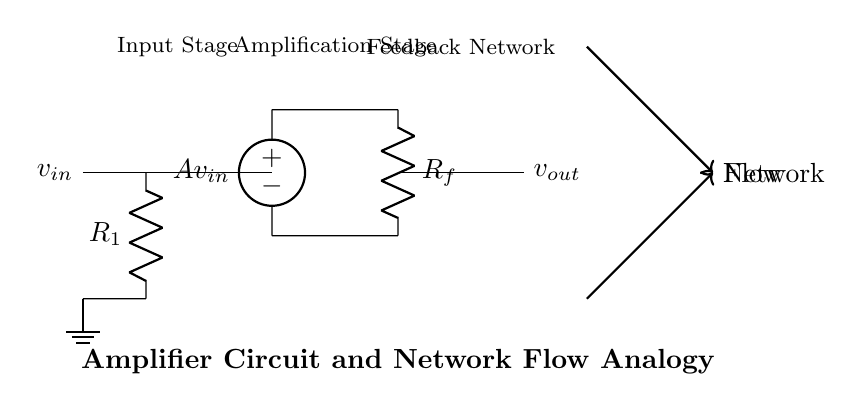what is the type of the amplifier used in the circuit? The circuit uses an operational amplifier, specifically an ideal one, as indicated by the configuration of the voltage source and resistors in the amplification stage.
Answer: operational amplifier what is the role of the resistor R1 in this circuit? Resistor R1 is a part of the input stage that determines the input impedance of the amplifier, working in conjunction with the input voltage to affect the initial current flow into the amplifier.
Answer: input impedance how does the feedback resistor Rf influence the output voltage? Rf creates a feedback loop essential for stabilizing and controlling the gain of the amplifier; it sets the relationship between the output voltage and the input voltage, thus impacting the overall amplification.
Answer: stabilizes gain what is the relationship between input voltage and output voltage in this circuit? The relationship is given by the formula vout = Av * vin, where Av is the gain of the amplifier determined by the resistors R1 and Rf, meaning the output voltage is a scaled version of the input voltage.
Answer: proportional what happens to the current if the value of the feedback resistor Rf is increased? Increasing Rf will generally result in a reduction of the overall gain of the amplifier, hence decreasing the output current for a constant input voltage while improving stability of the circuit.
Answer: decreases current which component is responsible for the amplification in the circuit? The operational amplifier itself is responsible for amplification, as it takes the input voltage through the voltage source and delivers an amplified output based on the feedback configuration.
Answer: operational amplifier 